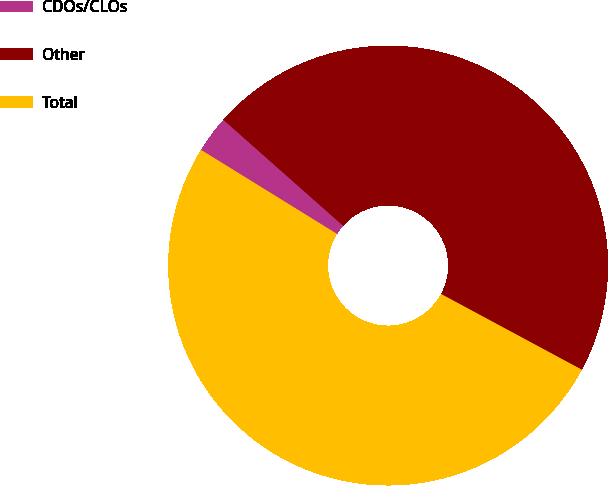Convert chart. <chart><loc_0><loc_0><loc_500><loc_500><pie_chart><fcel>CDOs/CLOs<fcel>Other<fcel>Total<nl><fcel>2.72%<fcel>46.32%<fcel>50.95%<nl></chart> 